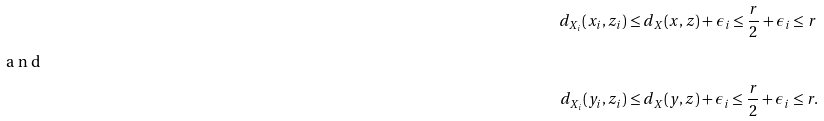Convert formula to latex. <formula><loc_0><loc_0><loc_500><loc_500>d _ { X _ { i } } ( x _ { i } , z _ { i } ) & \leq d _ { X } ( x , z ) + \epsilon _ { i } \leq \frac { r } { 2 } + \epsilon _ { i } \leq r \intertext { a n d } d _ { X _ { i } } ( y _ { i } , z _ { i } ) & \leq d _ { X } ( y , z ) + \epsilon _ { i } \leq \frac { r } { 2 } + \epsilon _ { i } \leq r .</formula> 